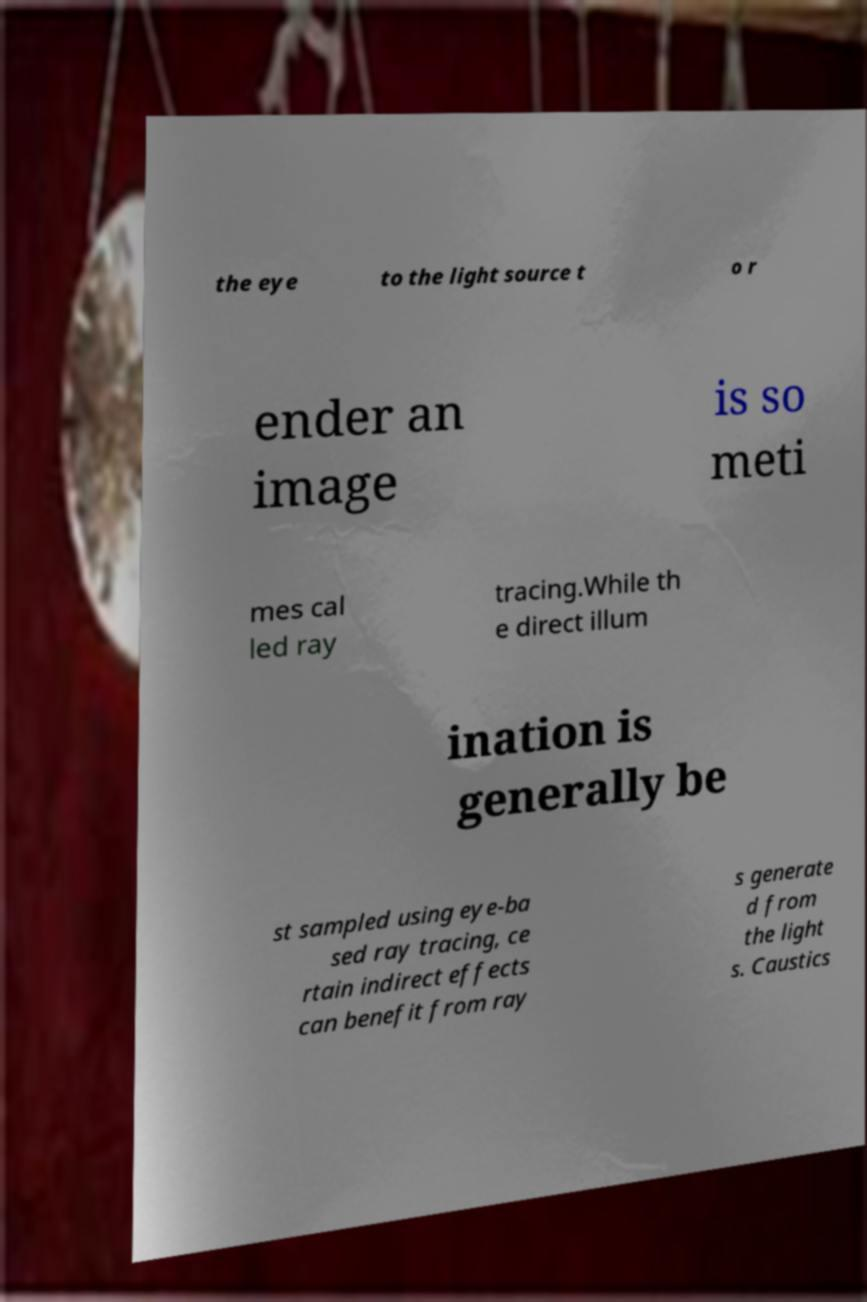Please identify and transcribe the text found in this image. the eye to the light source t o r ender an image is so meti mes cal led ray tracing.While th e direct illum ination is generally be st sampled using eye-ba sed ray tracing, ce rtain indirect effects can benefit from ray s generate d from the light s. Caustics 